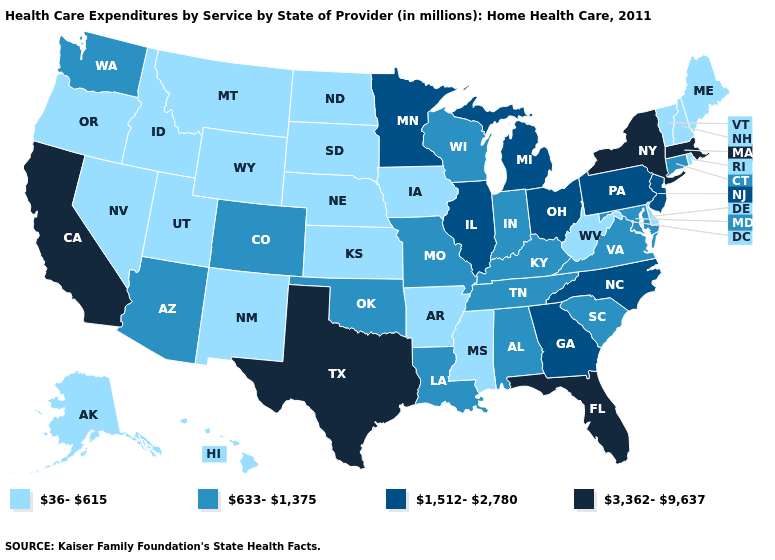Name the states that have a value in the range 633-1,375?
Be succinct. Alabama, Arizona, Colorado, Connecticut, Indiana, Kentucky, Louisiana, Maryland, Missouri, Oklahoma, South Carolina, Tennessee, Virginia, Washington, Wisconsin. Which states have the lowest value in the South?
Concise answer only. Arkansas, Delaware, Mississippi, West Virginia. Name the states that have a value in the range 633-1,375?
Keep it brief. Alabama, Arizona, Colorado, Connecticut, Indiana, Kentucky, Louisiana, Maryland, Missouri, Oklahoma, South Carolina, Tennessee, Virginia, Washington, Wisconsin. What is the value of New Hampshire?
Write a very short answer. 36-615. Name the states that have a value in the range 633-1,375?
Write a very short answer. Alabama, Arizona, Colorado, Connecticut, Indiana, Kentucky, Louisiana, Maryland, Missouri, Oklahoma, South Carolina, Tennessee, Virginia, Washington, Wisconsin. Does Washington have the lowest value in the West?
Concise answer only. No. Does Arizona have the same value as California?
Give a very brief answer. No. What is the highest value in states that border Colorado?
Be succinct. 633-1,375. What is the lowest value in states that border Maryland?
Quick response, please. 36-615. Does Louisiana have the same value as Iowa?
Give a very brief answer. No. Name the states that have a value in the range 633-1,375?
Concise answer only. Alabama, Arizona, Colorado, Connecticut, Indiana, Kentucky, Louisiana, Maryland, Missouri, Oklahoma, South Carolina, Tennessee, Virginia, Washington, Wisconsin. What is the lowest value in the USA?
Give a very brief answer. 36-615. What is the highest value in the USA?
Quick response, please. 3,362-9,637. Which states have the lowest value in the USA?
Short answer required. Alaska, Arkansas, Delaware, Hawaii, Idaho, Iowa, Kansas, Maine, Mississippi, Montana, Nebraska, Nevada, New Hampshire, New Mexico, North Dakota, Oregon, Rhode Island, South Dakota, Utah, Vermont, West Virginia, Wyoming. What is the value of North Carolina?
Be succinct. 1,512-2,780. 